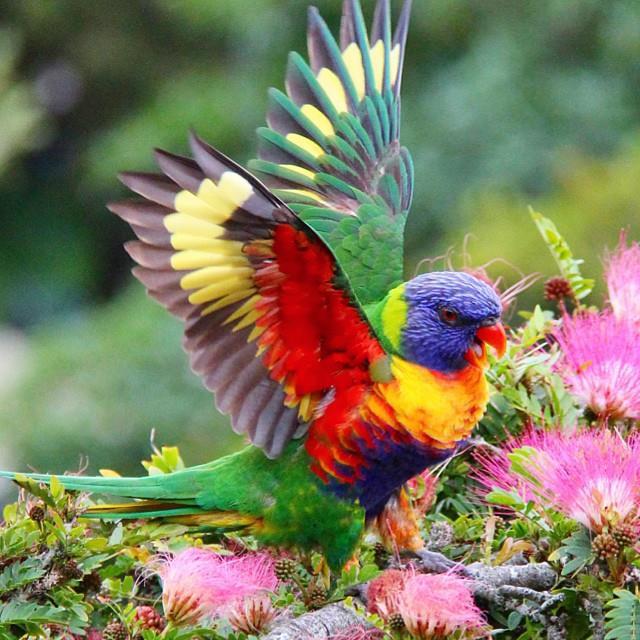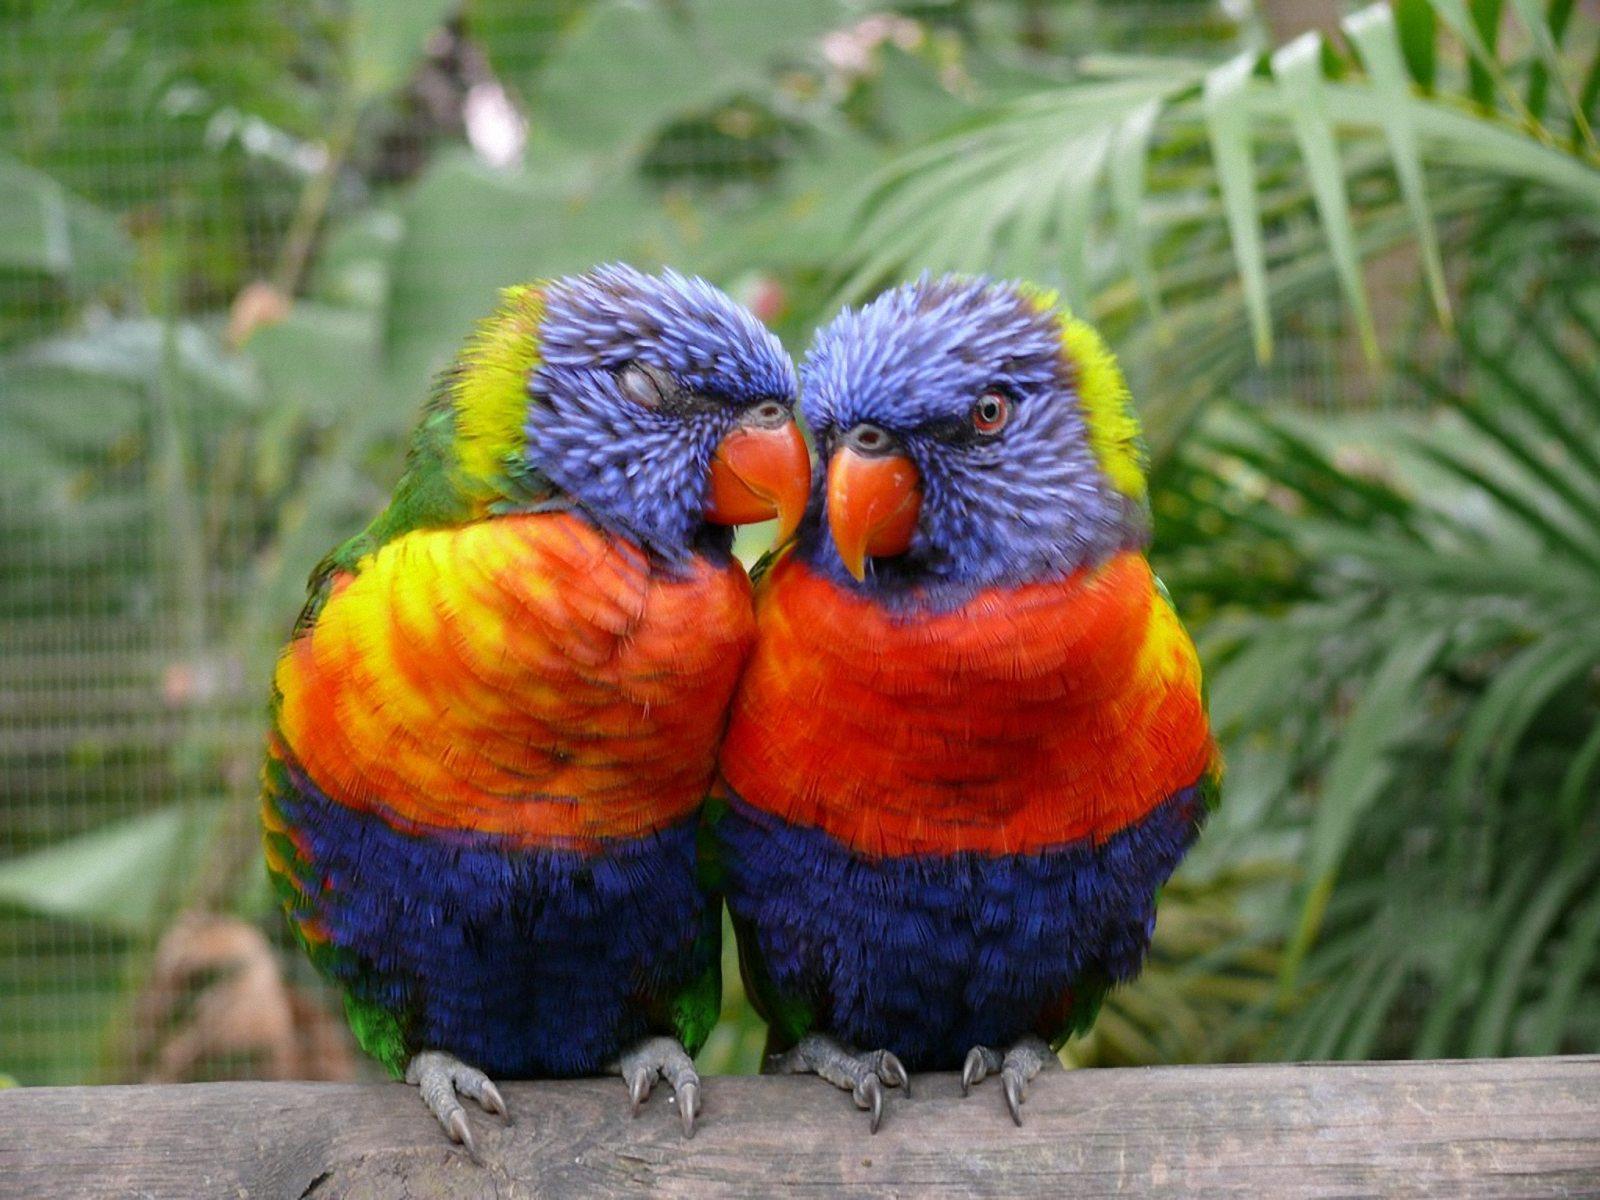The first image is the image on the left, the second image is the image on the right. Considering the images on both sides, is "Two birds share a branch in the image on the right." valid? Answer yes or no. Yes. 